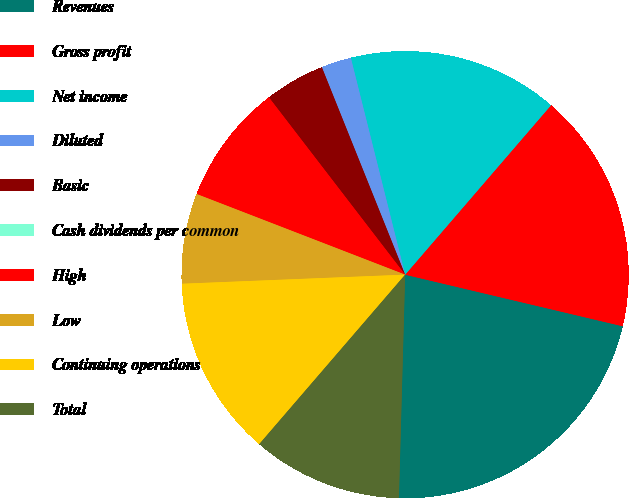Convert chart. <chart><loc_0><loc_0><loc_500><loc_500><pie_chart><fcel>Revenues<fcel>Gross profit<fcel>Net income<fcel>Diluted<fcel>Basic<fcel>Cash dividends per common<fcel>High<fcel>Low<fcel>Continuing operations<fcel>Total<nl><fcel>21.74%<fcel>17.39%<fcel>15.22%<fcel>2.17%<fcel>4.35%<fcel>0.0%<fcel>8.7%<fcel>6.52%<fcel>13.04%<fcel>10.87%<nl></chart> 